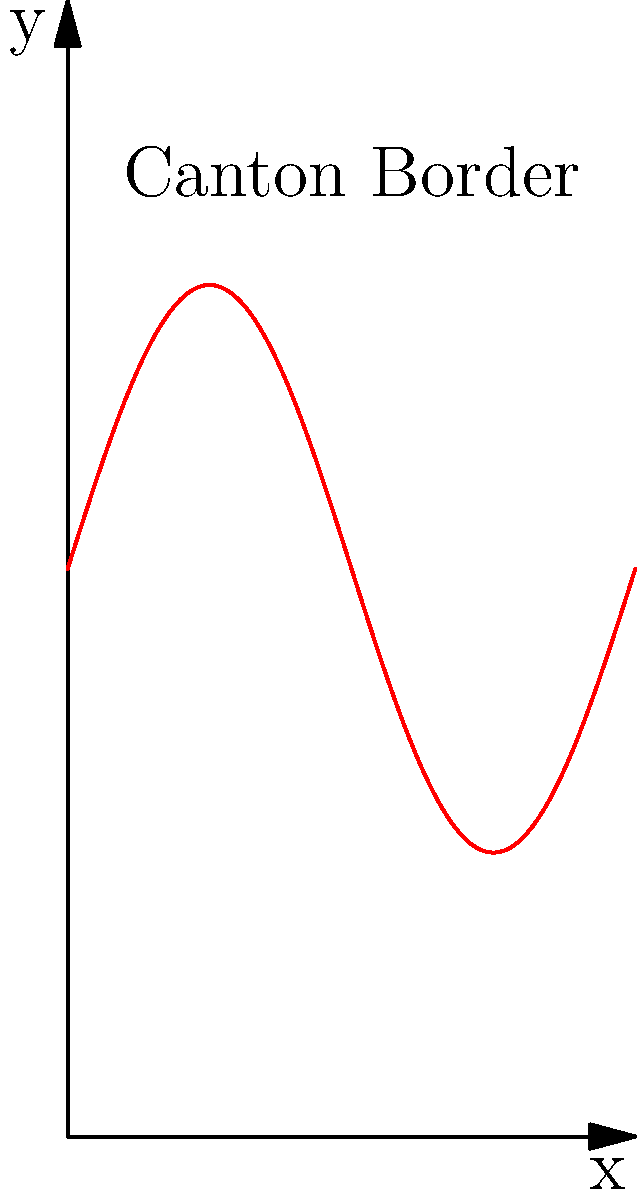Consider the historic border of a Swiss canton represented by the curve shown above. The curve is described by the function $f(x) = 0.5\sin(2\pi x) + 1$ over the interval $[0,1]$. Calculate the approximate perimeter of this border section using the arc length formula. Round your answer to two decimal places. To find the perimeter (arc length) of the curve, we'll use the arc length formula:

$L = \int_{a}^{b} \sqrt{1 + [f'(x)]^2} dx$

Steps:
1. Find $f'(x)$:
   $f'(x) = 0.5 \cdot 2\pi \cdot \cos(2\pi x) = \pi \cos(2\pi x)$

2. Substitute into the arc length formula:
   $L = \int_{0}^{1} \sqrt{1 + [\pi \cos(2\pi x)]^2} dx$

3. This integral cannot be solved analytically, so we need to use numerical integration. We can use Simpson's rule or a computer algebra system.

4. Using a numerical integration method, we get:
   $L \approx 1.3797$

5. Rounding to two decimal places:
   $L \approx 1.38$

Thus, the approximate perimeter of the canton border section is 1.38 units.
Answer: $1.38$ units 